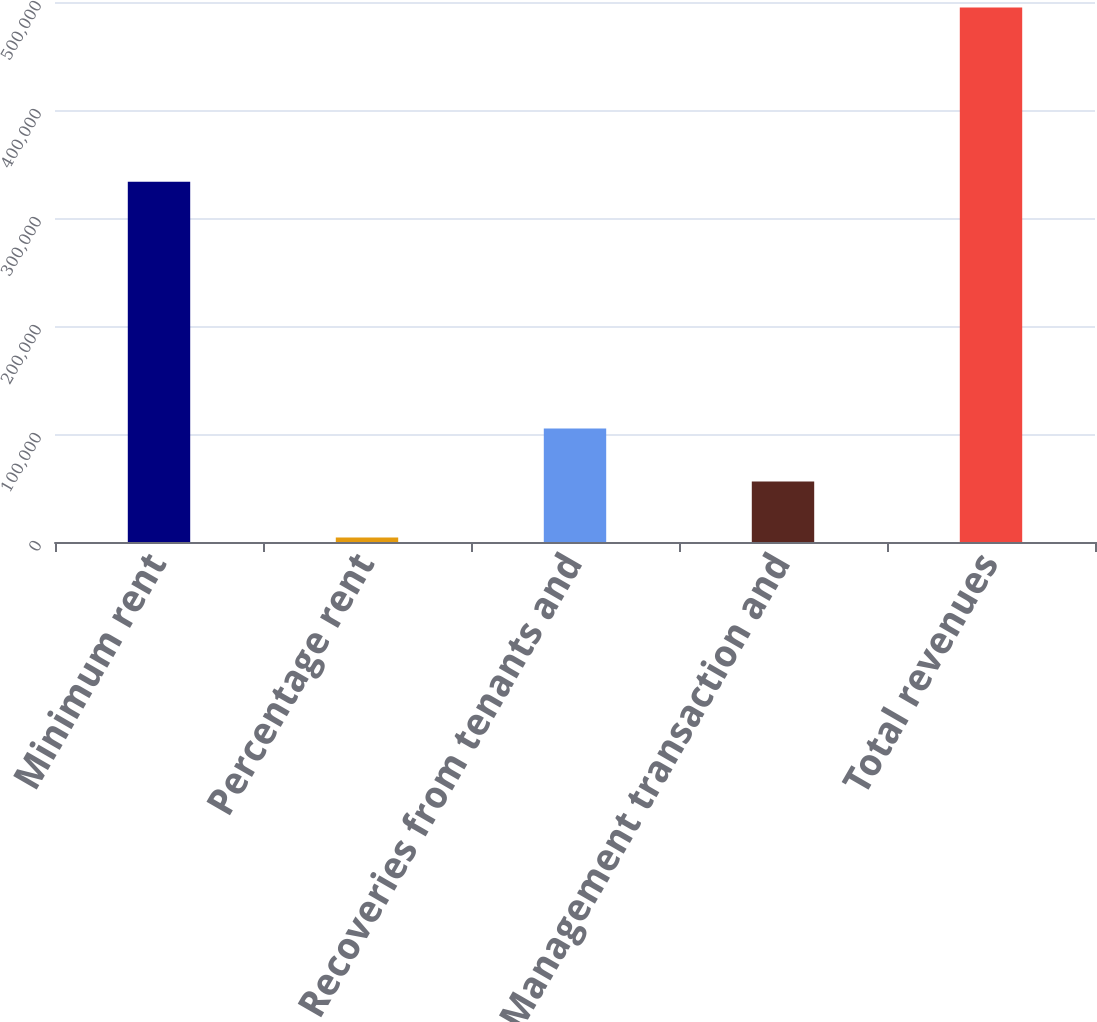Convert chart to OTSL. <chart><loc_0><loc_0><loc_500><loc_500><bar_chart><fcel>Minimum rent<fcel>Percentage rent<fcel>Recoveries from tenants and<fcel>Management transaction and<fcel>Total revenues<nl><fcel>333659<fcel>4258<fcel>105100<fcel>56032<fcel>494934<nl></chart> 